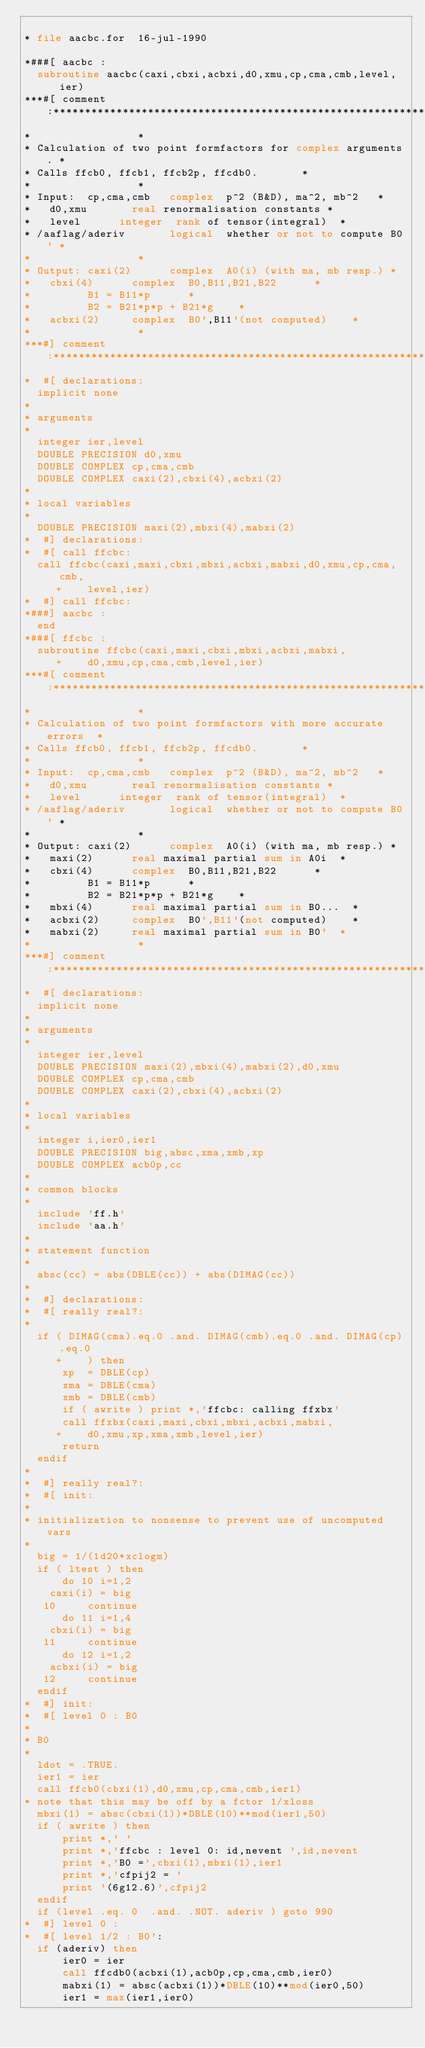<code> <loc_0><loc_0><loc_500><loc_500><_FORTRAN_>
* file aacbc.for  16-jul-1990

*###[ aacbc :
	subroutine aacbc(caxi,cbxi,acbxi,d0,xmu,cp,cma,cmb,level,ier)
***#[ comment:***********************************************************
*									*
*	Calculation of two point formfactors for complex arguments.	*
*	Calls ffcb0, ffcb1, ffcb2p, ffcdb0.				*
*									*
*	Input:	cp,cma,cmb   complex	p^2 (B&D), ma^2, mb^2		*
*		d0,xmu	     real	renormalisation constants	*
*		level	     integer	rank of tensor(integral)	*
*	/aaflag/aderiv	     logical	whether or not to compute B0'	*
*									*
*	Output:	caxi(2)	     complex	A0(i) (with ma, mb resp.)	*
*		cbxi(4)	     complex	B0,B11,B21,B22			*
*					B1 = B11*p			*
*					B2 = B21*p*p + B21*g		*
*		acbxi(2)     complex	B0',B11'(not computed)		*
*									*
***#] comment:***********************************************************
*  #[ declarations:
	implicit none
*
*	arguments
*
	integer ier,level
	DOUBLE PRECISION d0,xmu
	DOUBLE COMPLEX cp,cma,cmb
	DOUBLE COMPLEX caxi(2),cbxi(4),acbxi(2)
*
*	local variables
*
	DOUBLE PRECISION maxi(2),mbxi(4),mabxi(2)
*  #] declarations:
*  #[ call ffcbc:
	call ffcbc(caxi,maxi,cbxi,mbxi,acbxi,mabxi,d0,xmu,cp,cma,cmb,
     +		level,ier)
*  #] call ffcbc:
*###] aacbc :
	end
*###[ ffcbc :
	subroutine ffcbc(caxi,maxi,cbxi,mbxi,acbxi,mabxi,
     +		d0,xmu,cp,cma,cmb,level,ier)
***#[ comment:***********************************************************
*									*
*	Calculation of two point formfactors with more accurate errors	*
*	Calls ffcb0, ffcb1, ffcb2p, ffcdb0.				*
*									*
*	Input:	cp,cma,cmb   complex	p^2 (B&D), ma^2, mb^2		*
*		d0,xmu	     real	renormalisation constants	*
*		level	     integer	rank of tensor(integral)	*
*	/aaflag/aderiv	     logical	whether or not to compute B0'	*
*									*
*	Output:	caxi(2)	     complex	A0(i) (with ma, mb resp.)	*
*		maxi(2)	     real	maximal partial sum in A0i	*
*		cbxi(4)	     complex	B0,B11,B21,B22			*
*					B1 = B11*p			*
*					B2 = B21*p*p + B21*g		*
*		mbxi(4)	     real	maximal partial sum in B0...	*
*		acbxi(2)     complex	B0',B11'(not computed)		*
*		mabxi(2)     real	maximal partial sum in B0'	*
*									*
***#] comment:***********************************************************
*  #[ declarations:
	implicit none
*
*	arguments
*
	integer ier,level
	DOUBLE PRECISION maxi(2),mbxi(4),mabxi(2),d0,xmu
	DOUBLE COMPLEX cp,cma,cmb
	DOUBLE COMPLEX caxi(2),cbxi(4),acbxi(2)
*
*	local variables
*
	integer i,ier0,ier1
	DOUBLE PRECISION big,absc,xma,xmb,xp
	DOUBLE COMPLEX acb0p,cc
*
*	common blocks
*
	include 'ff.h'
	include 'aa.h'
*
*	statement function
*
	absc(cc) = abs(DBLE(cc)) + abs(DIMAG(cc))
*
*  #] declarations:
*  #[ really real?:
*
	if ( DIMAG(cma).eq.0 .and. DIMAG(cmb).eq.0 .and. DIMAG(cp).eq.0
     +		) then
	    xp  = DBLE(cp)
	    xma = DBLE(cma)
	    xmb = DBLE(cmb)
	    if ( awrite ) print *,'ffcbc: calling ffxbx'
	    call ffxbx(caxi,maxi,cbxi,mbxi,acbxi,mabxi,
     +		d0,xmu,xp,xma,xmb,level,ier)
	    return
	endif
*
*  #] really real?:
*  #[ init:
*
*	initialization to nonsense to prevent use of uncomputed vars
*
	big = 1/(1d20*xclogm)
	if ( ltest ) then
	    do 10 i=1,2
		caxi(i) = big
   10	    continue
	    do 11 i=1,4
		cbxi(i) = big
   11	    continue
	    do 12 i=1,2
		acbxi(i) = big
   12	    continue
	endif
*  #] init:
*  #[ level 0 : B0
*
*	B0
*
	ldot = .TRUE.
	ier1 = ier
	call ffcb0(cbxi(1),d0,xmu,cp,cma,cmb,ier1)
*	note that this may be off by a fctor 1/xloss
	mbxi(1) = absc(cbxi(1))*DBLE(10)**mod(ier1,50)
	if ( awrite ) then
	    print *,' '
	    print *,'ffcbc : level 0: id,nevent ',id,nevent
	    print *,'B0 =',cbxi(1),mbxi(1),ier1
	    print *,'cfpij2 = '
	    print '(6g12.6)',cfpij2
	endif
	if (level .eq. 0  .and. .NOT. aderiv ) goto 990
*  #] level 0 :
*  #[ level 1/2 : B0':
	if (aderiv) then
	    ier0 = ier
	    call ffcdb0(acbxi(1),acb0p,cp,cma,cmb,ier0)
	    mabxi(1) = absc(acbxi(1))*DBLE(10)**mod(ier0,50)
	    ier1 = max(ier1,ier0)</code> 